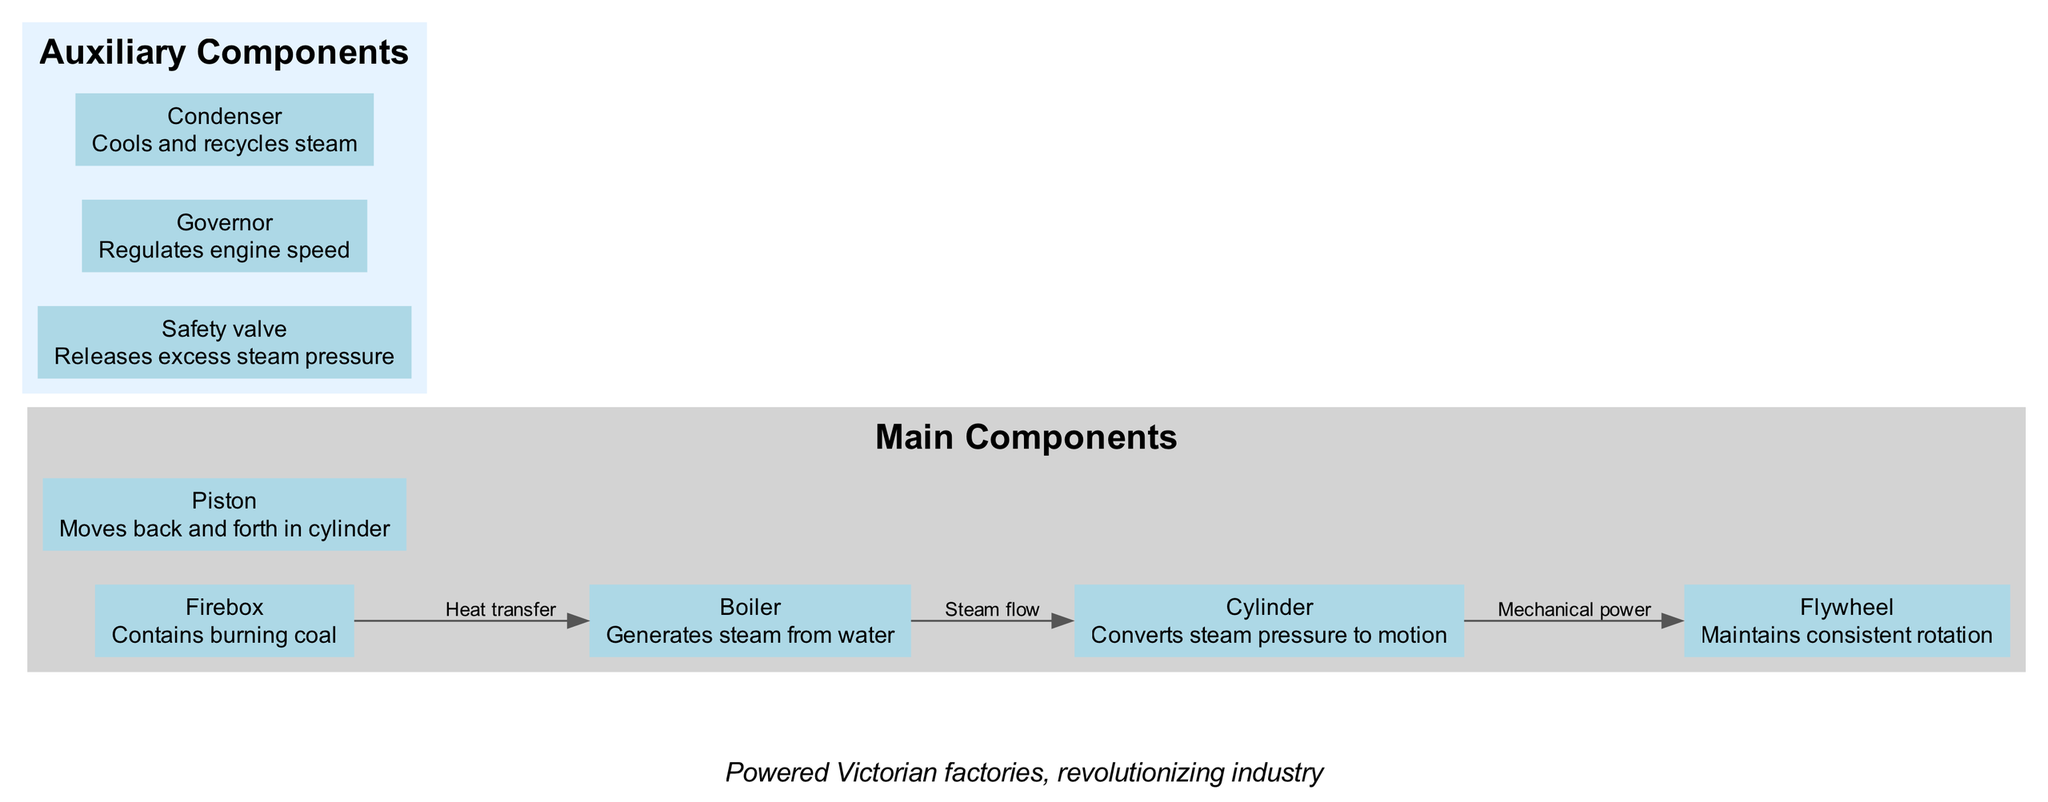What is the primary function of the Boiler? The diagram states that the Boiler generates steam from water, which is its primary purpose.
Answer: Generates steam from water How many main components are displayed in the diagram? By counting the items listed in the 'Main Components' section of the diagram, we find a total of five components: Boiler, Firebox, Cylinder, Piston, and Flywheel.
Answer: Five What process occurs between the Boiler and the Cylinder? The diagram shows that the process described between the Boiler and the Cylinder is 'Steam flow,' which highlights the movement of steam from one to the other.
Answer: Steam flow Which component is responsible for regulating engine speed? The diagram indicates that the Governor is the component that regulates engine speed, as it is listed in the auxiliary components section with that specific function.
Answer: Governor What are the two main products of heat transfer from the Firebox to the Boiler? In the diagram, while not explicitly stated as products, we can deduce that the heat transfer from the Firebox to the Boiler generates steam, which is necessary for the next processes, primarily affecting the Cylinder.
Answer: Steam What is the role of the Flywheel in this steam engine? The diagram describes the Flywheel's role as maintaining consistent rotation, which highlights its importance in stabilizing the engine's movement throughout its operation.
Answer: Maintains consistent rotation What does the Safety valve do in the steam engine? The diagram defines the Safety valve as releasing excess steam pressure, preventing potential hazards from pressure build-up in the system.
Answer: Releases excess steam pressure What is the historical significance mentioned in the diagram? According to the diagram, the historical context states that these engines powered Victorian factories, showcasing their crucial role in the industrial revolution.
Answer: Powered Victorian factories, revolutionizing industry 